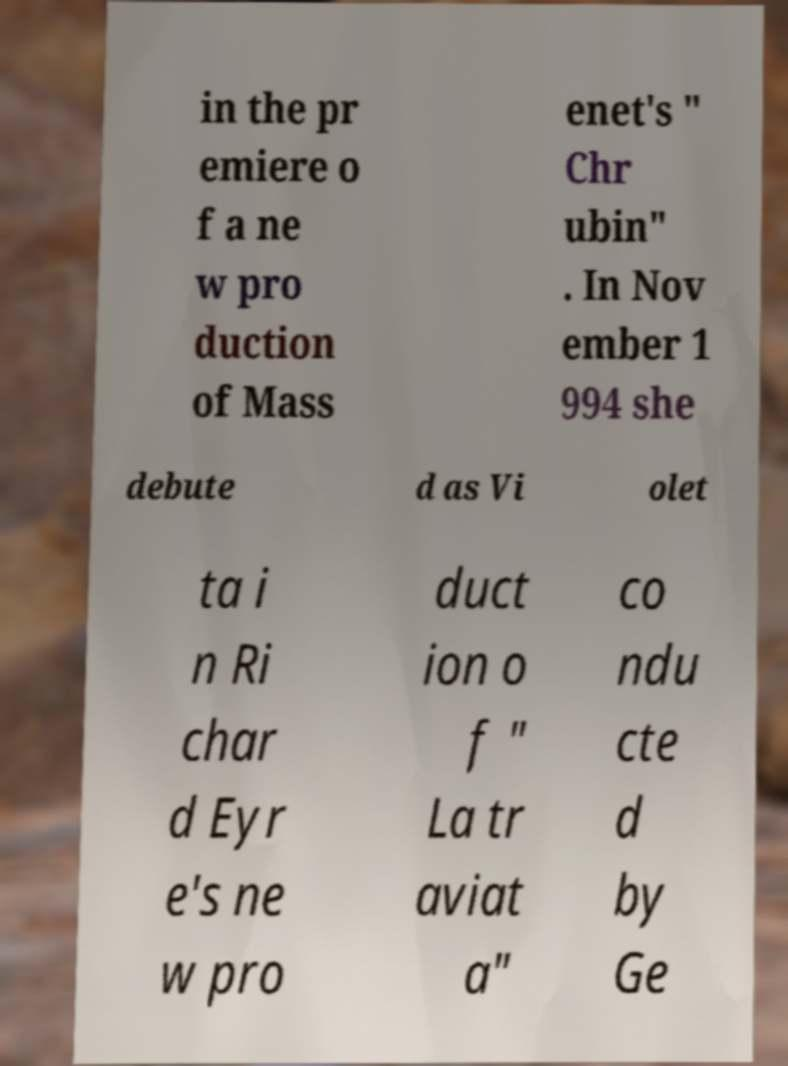What messages or text are displayed in this image? I need them in a readable, typed format. in the pr emiere o f a ne w pro duction of Mass enet's " Chr ubin" . In Nov ember 1 994 she debute d as Vi olet ta i n Ri char d Eyr e's ne w pro duct ion o f " La tr aviat a" co ndu cte d by Ge 